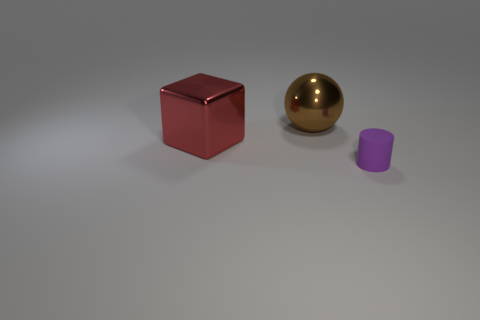How many other things are the same size as the sphere?
Offer a terse response. 1. What size is the thing in front of the big red shiny block in front of the big ball?
Provide a short and direct response. Small. What is the color of the big object that is in front of the large metal thing that is to the right of the object that is on the left side of the big brown thing?
Provide a short and direct response. Red. How big is the object that is both in front of the big brown metallic ball and behind the tiny cylinder?
Your response must be concise. Large. What number of other things are there of the same shape as the purple thing?
Offer a very short reply. 0. What number of cylinders are either large blue metallic objects or big red shiny objects?
Offer a terse response. 0. There is a thing to the right of the metallic thing that is behind the big metallic cube; are there any metallic blocks in front of it?
Your answer should be very brief. No. What number of yellow objects are either shiny cubes or shiny balls?
Make the answer very short. 0. The thing that is on the right side of the large shiny thing that is behind the big red thing is made of what material?
Ensure brevity in your answer.  Rubber. The metal object that is the same size as the brown sphere is what color?
Provide a succinct answer. Red. 